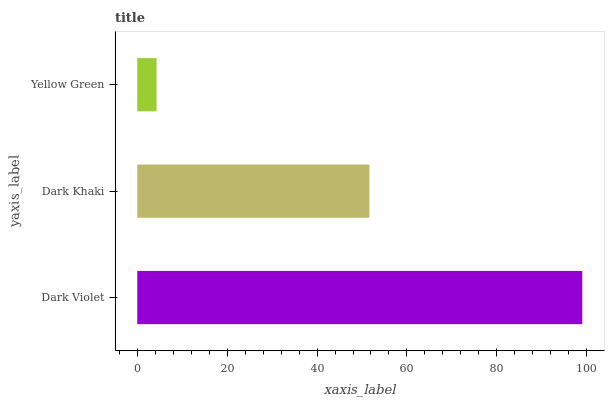Is Yellow Green the minimum?
Answer yes or no. Yes. Is Dark Violet the maximum?
Answer yes or no. Yes. Is Dark Khaki the minimum?
Answer yes or no. No. Is Dark Khaki the maximum?
Answer yes or no. No. Is Dark Violet greater than Dark Khaki?
Answer yes or no. Yes. Is Dark Khaki less than Dark Violet?
Answer yes or no. Yes. Is Dark Khaki greater than Dark Violet?
Answer yes or no. No. Is Dark Violet less than Dark Khaki?
Answer yes or no. No. Is Dark Khaki the high median?
Answer yes or no. Yes. Is Dark Khaki the low median?
Answer yes or no. Yes. Is Dark Violet the high median?
Answer yes or no. No. Is Yellow Green the low median?
Answer yes or no. No. 